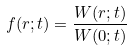<formula> <loc_0><loc_0><loc_500><loc_500>f ( r ; t ) = \frac { W ( r ; t ) } { W ( 0 ; t ) }</formula> 